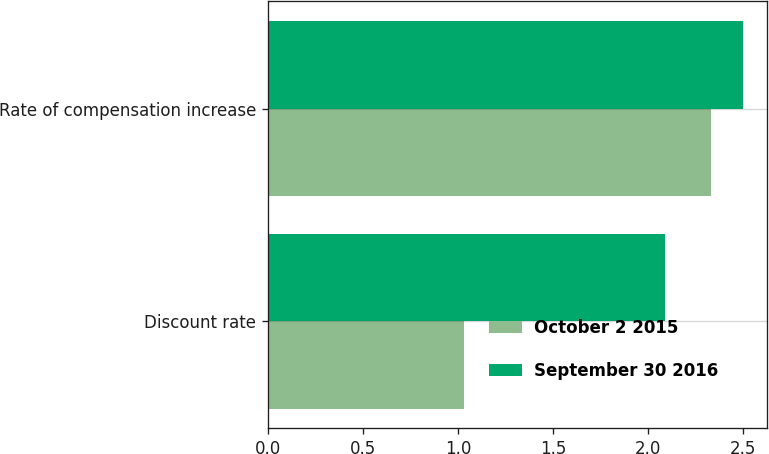<chart> <loc_0><loc_0><loc_500><loc_500><stacked_bar_chart><ecel><fcel>Discount rate<fcel>Rate of compensation increase<nl><fcel>October 2 2015<fcel>1.03<fcel>2.33<nl><fcel>September 30 2016<fcel>2.09<fcel>2.5<nl></chart> 